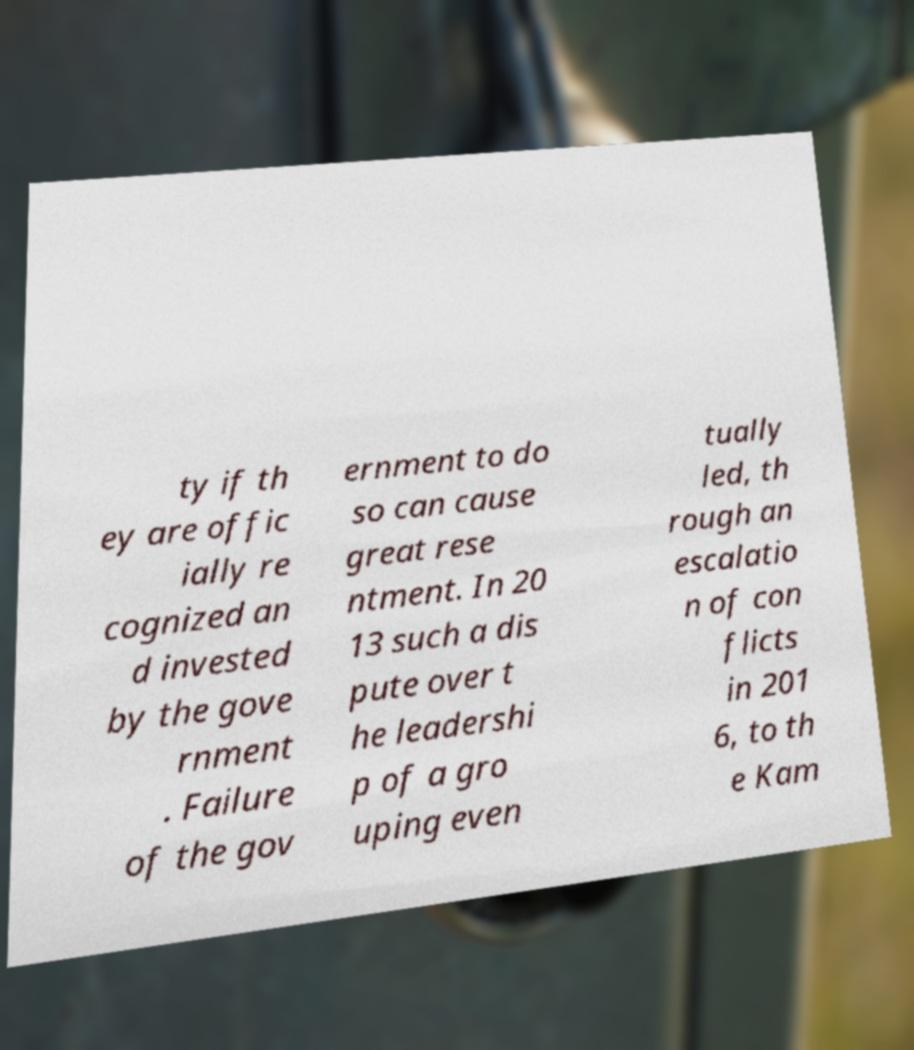Can you read and provide the text displayed in the image?This photo seems to have some interesting text. Can you extract and type it out for me? ty if th ey are offic ially re cognized an d invested by the gove rnment . Failure of the gov ernment to do so can cause great rese ntment. In 20 13 such a dis pute over t he leadershi p of a gro uping even tually led, th rough an escalatio n of con flicts in 201 6, to th e Kam 